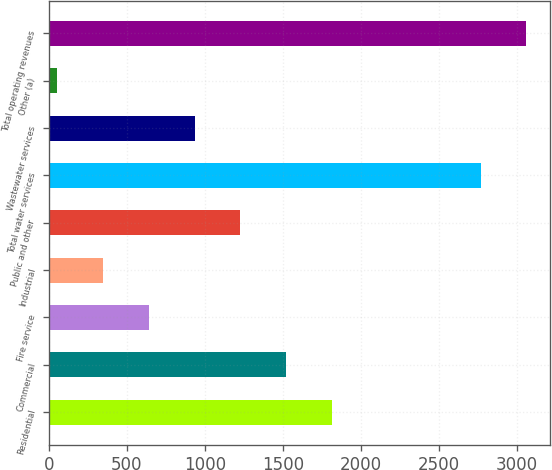<chart> <loc_0><loc_0><loc_500><loc_500><bar_chart><fcel>Residential<fcel>Commercial<fcel>Fire service<fcel>Industrial<fcel>Public and other<fcel>Total water services<fcel>Wastewater services<fcel>Other (a)<fcel>Total operating revenues<nl><fcel>1812.4<fcel>1519.5<fcel>640.8<fcel>347.9<fcel>1226.6<fcel>2768<fcel>933.7<fcel>55<fcel>3060.9<nl></chart> 